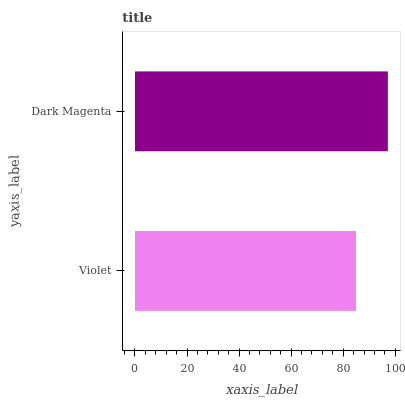Is Violet the minimum?
Answer yes or no. Yes. Is Dark Magenta the maximum?
Answer yes or no. Yes. Is Dark Magenta the minimum?
Answer yes or no. No. Is Dark Magenta greater than Violet?
Answer yes or no. Yes. Is Violet less than Dark Magenta?
Answer yes or no. Yes. Is Violet greater than Dark Magenta?
Answer yes or no. No. Is Dark Magenta less than Violet?
Answer yes or no. No. Is Dark Magenta the high median?
Answer yes or no. Yes. Is Violet the low median?
Answer yes or no. Yes. Is Violet the high median?
Answer yes or no. No. Is Dark Magenta the low median?
Answer yes or no. No. 